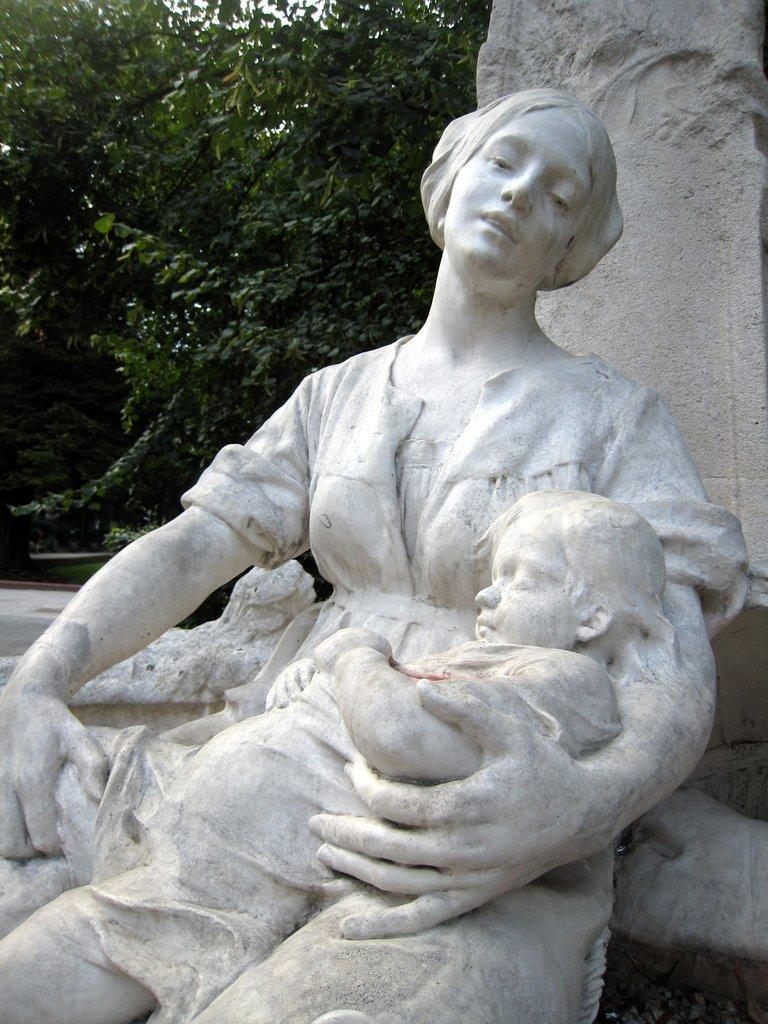Can you describe this image briefly? In this image there is a woman statue holding a baby on her lap. Behind the statue there is a wall. Left side there are few trees. 